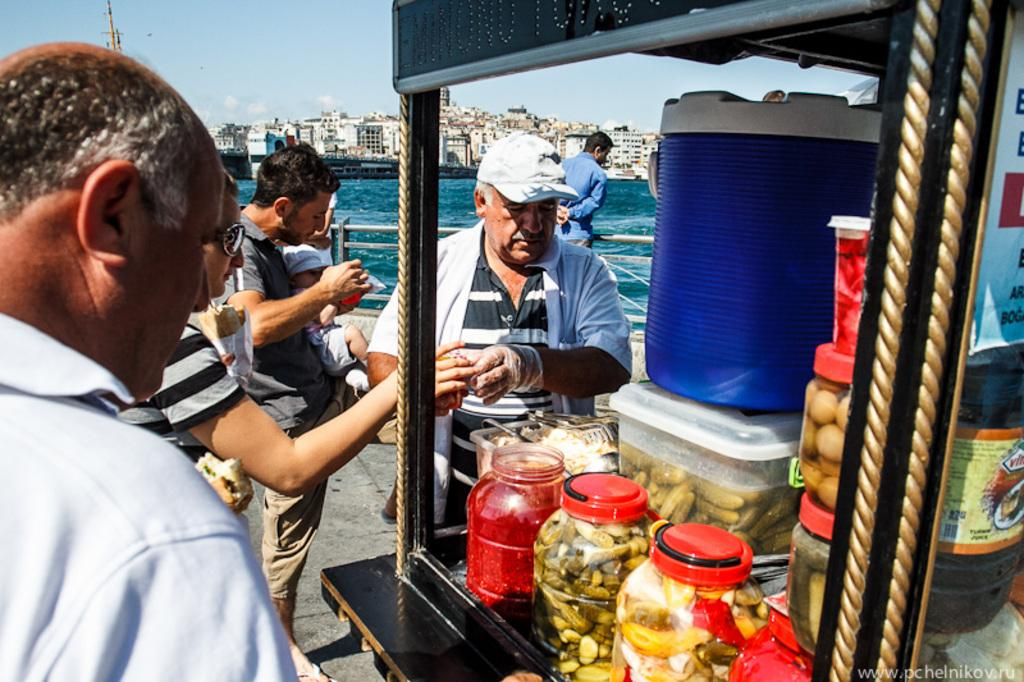What is happening in the image? There are persons standing in the image. What can be seen in the foreground of the image? There is a food stall in the image. What is visible in the background of the image? There are buildings in the background of the image. What is the condition of the sky in the image? Clouds are visible in the sky at the top of the image. How many geese are sleeping in the bedroom in the image? There are no geese or bedrooms present in the image. What type of team is visible in the image? There is no team visible in the image; it features persons standing near a food stall. 